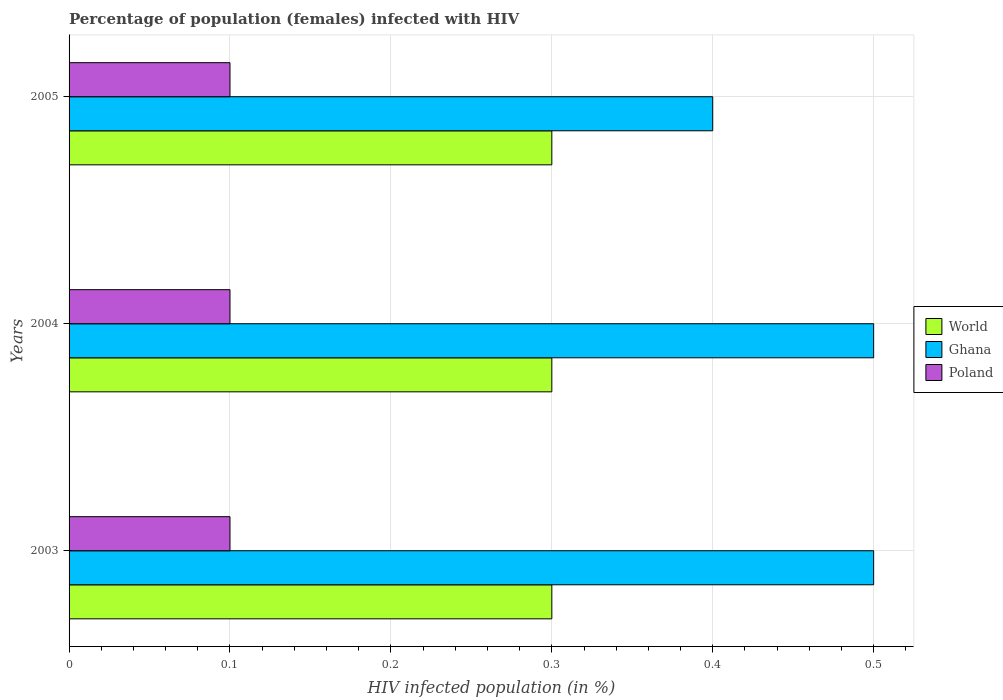How many different coloured bars are there?
Provide a short and direct response. 3. How many groups of bars are there?
Make the answer very short. 3. Are the number of bars per tick equal to the number of legend labels?
Make the answer very short. Yes. Are the number of bars on each tick of the Y-axis equal?
Provide a short and direct response. Yes. How many bars are there on the 1st tick from the bottom?
Make the answer very short. 3. What is the label of the 2nd group of bars from the top?
Provide a short and direct response. 2004. Across all years, what is the maximum percentage of HIV infected female population in World?
Keep it short and to the point. 0.3. Across all years, what is the minimum percentage of HIV infected female population in Ghana?
Offer a very short reply. 0.4. What is the total percentage of HIV infected female population in Poland in the graph?
Offer a terse response. 0.3. What is the difference between the percentage of HIV infected female population in Ghana in 2004 and the percentage of HIV infected female population in World in 2005?
Provide a succinct answer. 0.2. What is the average percentage of HIV infected female population in Ghana per year?
Keep it short and to the point. 0.47. In the year 2005, what is the difference between the percentage of HIV infected female population in Poland and percentage of HIV infected female population in World?
Offer a terse response. -0.2. In how many years, is the percentage of HIV infected female population in Poland greater than 0.32000000000000006 %?
Make the answer very short. 0. What is the ratio of the percentage of HIV infected female population in Poland in 2003 to that in 2005?
Make the answer very short. 1. Is the percentage of HIV infected female population in Poland in 2004 less than that in 2005?
Keep it short and to the point. No. Is the difference between the percentage of HIV infected female population in Poland in 2003 and 2005 greater than the difference between the percentage of HIV infected female population in World in 2003 and 2005?
Ensure brevity in your answer.  No. What is the difference between the highest and the lowest percentage of HIV infected female population in World?
Your answer should be very brief. 0. In how many years, is the percentage of HIV infected female population in Ghana greater than the average percentage of HIV infected female population in Ghana taken over all years?
Ensure brevity in your answer.  2. Is the sum of the percentage of HIV infected female population in Poland in 2003 and 2005 greater than the maximum percentage of HIV infected female population in Ghana across all years?
Keep it short and to the point. No. What does the 3rd bar from the top in 2005 represents?
Make the answer very short. World. What does the 1st bar from the bottom in 2005 represents?
Offer a terse response. World. Is it the case that in every year, the sum of the percentage of HIV infected female population in World and percentage of HIV infected female population in Ghana is greater than the percentage of HIV infected female population in Poland?
Your answer should be very brief. Yes. How many bars are there?
Make the answer very short. 9. Are all the bars in the graph horizontal?
Make the answer very short. Yes. How many years are there in the graph?
Ensure brevity in your answer.  3. Are the values on the major ticks of X-axis written in scientific E-notation?
Ensure brevity in your answer.  No. Where does the legend appear in the graph?
Your answer should be compact. Center right. What is the title of the graph?
Your answer should be compact. Percentage of population (females) infected with HIV. Does "Tanzania" appear as one of the legend labels in the graph?
Your answer should be compact. No. What is the label or title of the X-axis?
Provide a short and direct response. HIV infected population (in %). What is the label or title of the Y-axis?
Keep it short and to the point. Years. What is the HIV infected population (in %) of Ghana in 2003?
Make the answer very short. 0.5. What is the HIV infected population (in %) of Ghana in 2004?
Keep it short and to the point. 0.5. What is the HIV infected population (in %) of Poland in 2004?
Ensure brevity in your answer.  0.1. Across all years, what is the maximum HIV infected population (in %) in World?
Keep it short and to the point. 0.3. Across all years, what is the maximum HIV infected population (in %) of Ghana?
Keep it short and to the point. 0.5. Across all years, what is the maximum HIV infected population (in %) in Poland?
Give a very brief answer. 0.1. Across all years, what is the minimum HIV infected population (in %) in Poland?
Ensure brevity in your answer.  0.1. What is the total HIV infected population (in %) in World in the graph?
Offer a terse response. 0.9. What is the difference between the HIV infected population (in %) of World in 2003 and that in 2004?
Give a very brief answer. 0. What is the difference between the HIV infected population (in %) of Ghana in 2003 and that in 2004?
Your answer should be very brief. 0. What is the difference between the HIV infected population (in %) in World in 2003 and that in 2005?
Keep it short and to the point. 0. What is the difference between the HIV infected population (in %) of Ghana in 2003 and that in 2005?
Your response must be concise. 0.1. What is the difference between the HIV infected population (in %) in Poland in 2003 and that in 2005?
Your answer should be compact. 0. What is the difference between the HIV infected population (in %) of World in 2004 and that in 2005?
Keep it short and to the point. 0. What is the difference between the HIV infected population (in %) of Ghana in 2004 and that in 2005?
Your answer should be very brief. 0.1. What is the difference between the HIV infected population (in %) in World in 2003 and the HIV infected population (in %) in Ghana in 2004?
Your answer should be compact. -0.2. What is the difference between the HIV infected population (in %) in World in 2003 and the HIV infected population (in %) in Poland in 2004?
Your answer should be very brief. 0.2. What is the difference between the HIV infected population (in %) in Ghana in 2003 and the HIV infected population (in %) in Poland in 2004?
Make the answer very short. 0.4. What is the average HIV infected population (in %) in Ghana per year?
Provide a short and direct response. 0.47. In the year 2004, what is the difference between the HIV infected population (in %) of World and HIV infected population (in %) of Ghana?
Offer a terse response. -0.2. In the year 2004, what is the difference between the HIV infected population (in %) in World and HIV infected population (in %) in Poland?
Provide a succinct answer. 0.2. In the year 2004, what is the difference between the HIV infected population (in %) of Ghana and HIV infected population (in %) of Poland?
Your answer should be very brief. 0.4. In the year 2005, what is the difference between the HIV infected population (in %) of World and HIV infected population (in %) of Ghana?
Give a very brief answer. -0.1. In the year 2005, what is the difference between the HIV infected population (in %) of World and HIV infected population (in %) of Poland?
Provide a succinct answer. 0.2. What is the ratio of the HIV infected population (in %) of World in 2003 to that in 2004?
Give a very brief answer. 1. What is the ratio of the HIV infected population (in %) in Ghana in 2003 to that in 2005?
Give a very brief answer. 1.25. What is the ratio of the HIV infected population (in %) of World in 2004 to that in 2005?
Make the answer very short. 1. What is the ratio of the HIV infected population (in %) of Ghana in 2004 to that in 2005?
Offer a terse response. 1.25. What is the difference between the highest and the lowest HIV infected population (in %) in World?
Offer a very short reply. 0. What is the difference between the highest and the lowest HIV infected population (in %) in Ghana?
Provide a succinct answer. 0.1. What is the difference between the highest and the lowest HIV infected population (in %) in Poland?
Provide a short and direct response. 0. 